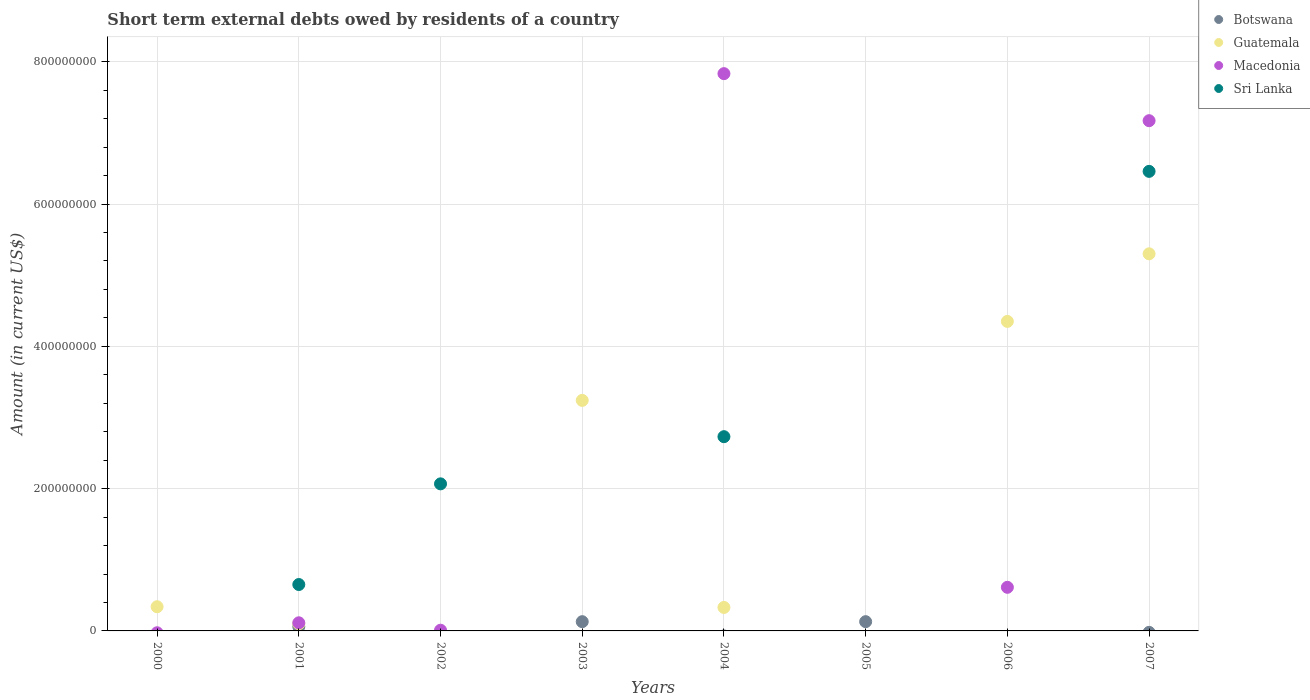How many different coloured dotlines are there?
Your answer should be compact. 4. What is the amount of short-term external debts owed by residents in Sri Lanka in 2000?
Provide a short and direct response. 0. Across all years, what is the maximum amount of short-term external debts owed by residents in Botswana?
Provide a short and direct response. 1.30e+07. What is the total amount of short-term external debts owed by residents in Macedonia in the graph?
Give a very brief answer. 1.57e+09. What is the difference between the amount of short-term external debts owed by residents in Sri Lanka in 2002 and that in 2004?
Keep it short and to the point. -6.63e+07. What is the difference between the amount of short-term external debts owed by residents in Sri Lanka in 2003 and the amount of short-term external debts owed by residents in Guatemala in 2005?
Your response must be concise. 0. In the year 2001, what is the difference between the amount of short-term external debts owed by residents in Botswana and amount of short-term external debts owed by residents in Sri Lanka?
Provide a short and direct response. -5.92e+07. In how many years, is the amount of short-term external debts owed by residents in Sri Lanka greater than 320000000 US$?
Your answer should be compact. 1. What is the ratio of the amount of short-term external debts owed by residents in Guatemala in 2000 to that in 2003?
Your response must be concise. 0.1. Is the amount of short-term external debts owed by residents in Macedonia in 2001 less than that in 2006?
Offer a terse response. Yes. What is the difference between the highest and the second highest amount of short-term external debts owed by residents in Macedonia?
Keep it short and to the point. 6.61e+07. What is the difference between the highest and the lowest amount of short-term external debts owed by residents in Botswana?
Your answer should be very brief. 1.30e+07. In how many years, is the amount of short-term external debts owed by residents in Sri Lanka greater than the average amount of short-term external debts owed by residents in Sri Lanka taken over all years?
Offer a very short reply. 3. How many years are there in the graph?
Provide a short and direct response. 8. What is the difference between two consecutive major ticks on the Y-axis?
Provide a short and direct response. 2.00e+08. Are the values on the major ticks of Y-axis written in scientific E-notation?
Ensure brevity in your answer.  No. Does the graph contain any zero values?
Your answer should be compact. Yes. Where does the legend appear in the graph?
Your answer should be very brief. Top right. How many legend labels are there?
Give a very brief answer. 4. What is the title of the graph?
Your response must be concise. Short term external debts owed by residents of a country. What is the label or title of the X-axis?
Give a very brief answer. Years. What is the Amount (in current US$) in Guatemala in 2000?
Provide a short and direct response. 3.40e+07. What is the Amount (in current US$) in Macedonia in 2000?
Make the answer very short. 0. What is the Amount (in current US$) in Macedonia in 2001?
Offer a very short reply. 1.14e+07. What is the Amount (in current US$) in Sri Lanka in 2001?
Your response must be concise. 6.52e+07. What is the Amount (in current US$) of Macedonia in 2002?
Make the answer very short. 9.95e+05. What is the Amount (in current US$) of Sri Lanka in 2002?
Make the answer very short. 2.07e+08. What is the Amount (in current US$) in Botswana in 2003?
Ensure brevity in your answer.  1.30e+07. What is the Amount (in current US$) in Guatemala in 2003?
Offer a very short reply. 3.24e+08. What is the Amount (in current US$) in Botswana in 2004?
Offer a terse response. 0. What is the Amount (in current US$) in Guatemala in 2004?
Your response must be concise. 3.30e+07. What is the Amount (in current US$) in Macedonia in 2004?
Ensure brevity in your answer.  7.83e+08. What is the Amount (in current US$) of Sri Lanka in 2004?
Offer a terse response. 2.73e+08. What is the Amount (in current US$) in Botswana in 2005?
Provide a short and direct response. 1.30e+07. What is the Amount (in current US$) of Macedonia in 2005?
Make the answer very short. 0. What is the Amount (in current US$) of Botswana in 2006?
Give a very brief answer. 0. What is the Amount (in current US$) in Guatemala in 2006?
Keep it short and to the point. 4.35e+08. What is the Amount (in current US$) in Macedonia in 2006?
Provide a short and direct response. 6.13e+07. What is the Amount (in current US$) of Sri Lanka in 2006?
Offer a very short reply. 0. What is the Amount (in current US$) in Botswana in 2007?
Give a very brief answer. 0. What is the Amount (in current US$) in Guatemala in 2007?
Provide a succinct answer. 5.30e+08. What is the Amount (in current US$) of Macedonia in 2007?
Your answer should be very brief. 7.17e+08. What is the Amount (in current US$) in Sri Lanka in 2007?
Give a very brief answer. 6.46e+08. Across all years, what is the maximum Amount (in current US$) in Botswana?
Your answer should be very brief. 1.30e+07. Across all years, what is the maximum Amount (in current US$) of Guatemala?
Your answer should be compact. 5.30e+08. Across all years, what is the maximum Amount (in current US$) of Macedonia?
Make the answer very short. 7.83e+08. Across all years, what is the maximum Amount (in current US$) in Sri Lanka?
Your answer should be compact. 6.46e+08. Across all years, what is the minimum Amount (in current US$) in Macedonia?
Make the answer very short. 0. What is the total Amount (in current US$) of Botswana in the graph?
Your answer should be compact. 3.20e+07. What is the total Amount (in current US$) of Guatemala in the graph?
Keep it short and to the point. 1.37e+09. What is the total Amount (in current US$) of Macedonia in the graph?
Ensure brevity in your answer.  1.57e+09. What is the total Amount (in current US$) of Sri Lanka in the graph?
Make the answer very short. 1.19e+09. What is the difference between the Amount (in current US$) of Guatemala in 2000 and that in 2001?
Your answer should be very brief. 2.40e+07. What is the difference between the Amount (in current US$) in Guatemala in 2000 and that in 2003?
Keep it short and to the point. -2.90e+08. What is the difference between the Amount (in current US$) in Guatemala in 2000 and that in 2006?
Keep it short and to the point. -4.01e+08. What is the difference between the Amount (in current US$) in Guatemala in 2000 and that in 2007?
Provide a short and direct response. -4.96e+08. What is the difference between the Amount (in current US$) in Macedonia in 2001 and that in 2002?
Provide a short and direct response. 1.04e+07. What is the difference between the Amount (in current US$) of Sri Lanka in 2001 and that in 2002?
Provide a short and direct response. -1.41e+08. What is the difference between the Amount (in current US$) of Botswana in 2001 and that in 2003?
Your answer should be compact. -7.00e+06. What is the difference between the Amount (in current US$) of Guatemala in 2001 and that in 2003?
Keep it short and to the point. -3.14e+08. What is the difference between the Amount (in current US$) of Guatemala in 2001 and that in 2004?
Provide a succinct answer. -2.30e+07. What is the difference between the Amount (in current US$) of Macedonia in 2001 and that in 2004?
Give a very brief answer. -7.72e+08. What is the difference between the Amount (in current US$) in Sri Lanka in 2001 and that in 2004?
Make the answer very short. -2.08e+08. What is the difference between the Amount (in current US$) in Botswana in 2001 and that in 2005?
Give a very brief answer. -7.00e+06. What is the difference between the Amount (in current US$) of Guatemala in 2001 and that in 2006?
Give a very brief answer. -4.25e+08. What is the difference between the Amount (in current US$) of Macedonia in 2001 and that in 2006?
Your answer should be compact. -4.99e+07. What is the difference between the Amount (in current US$) of Guatemala in 2001 and that in 2007?
Offer a terse response. -5.20e+08. What is the difference between the Amount (in current US$) of Macedonia in 2001 and that in 2007?
Give a very brief answer. -7.06e+08. What is the difference between the Amount (in current US$) of Sri Lanka in 2001 and that in 2007?
Your answer should be compact. -5.81e+08. What is the difference between the Amount (in current US$) in Macedonia in 2002 and that in 2004?
Offer a very short reply. -7.82e+08. What is the difference between the Amount (in current US$) of Sri Lanka in 2002 and that in 2004?
Provide a succinct answer. -6.63e+07. What is the difference between the Amount (in current US$) in Macedonia in 2002 and that in 2006?
Ensure brevity in your answer.  -6.03e+07. What is the difference between the Amount (in current US$) in Macedonia in 2002 and that in 2007?
Make the answer very short. -7.16e+08. What is the difference between the Amount (in current US$) of Sri Lanka in 2002 and that in 2007?
Your response must be concise. -4.39e+08. What is the difference between the Amount (in current US$) of Guatemala in 2003 and that in 2004?
Your answer should be compact. 2.91e+08. What is the difference between the Amount (in current US$) in Botswana in 2003 and that in 2005?
Offer a terse response. 0. What is the difference between the Amount (in current US$) of Guatemala in 2003 and that in 2006?
Give a very brief answer. -1.11e+08. What is the difference between the Amount (in current US$) of Guatemala in 2003 and that in 2007?
Your answer should be very brief. -2.06e+08. What is the difference between the Amount (in current US$) in Guatemala in 2004 and that in 2006?
Your answer should be very brief. -4.02e+08. What is the difference between the Amount (in current US$) of Macedonia in 2004 and that in 2006?
Offer a terse response. 7.22e+08. What is the difference between the Amount (in current US$) in Guatemala in 2004 and that in 2007?
Ensure brevity in your answer.  -4.97e+08. What is the difference between the Amount (in current US$) of Macedonia in 2004 and that in 2007?
Your response must be concise. 6.61e+07. What is the difference between the Amount (in current US$) in Sri Lanka in 2004 and that in 2007?
Your answer should be very brief. -3.73e+08. What is the difference between the Amount (in current US$) in Guatemala in 2006 and that in 2007?
Make the answer very short. -9.50e+07. What is the difference between the Amount (in current US$) of Macedonia in 2006 and that in 2007?
Your response must be concise. -6.56e+08. What is the difference between the Amount (in current US$) in Guatemala in 2000 and the Amount (in current US$) in Macedonia in 2001?
Offer a very short reply. 2.26e+07. What is the difference between the Amount (in current US$) in Guatemala in 2000 and the Amount (in current US$) in Sri Lanka in 2001?
Make the answer very short. -3.12e+07. What is the difference between the Amount (in current US$) in Guatemala in 2000 and the Amount (in current US$) in Macedonia in 2002?
Offer a very short reply. 3.30e+07. What is the difference between the Amount (in current US$) in Guatemala in 2000 and the Amount (in current US$) in Sri Lanka in 2002?
Ensure brevity in your answer.  -1.73e+08. What is the difference between the Amount (in current US$) of Guatemala in 2000 and the Amount (in current US$) of Macedonia in 2004?
Provide a succinct answer. -7.49e+08. What is the difference between the Amount (in current US$) in Guatemala in 2000 and the Amount (in current US$) in Sri Lanka in 2004?
Provide a succinct answer. -2.39e+08. What is the difference between the Amount (in current US$) of Guatemala in 2000 and the Amount (in current US$) of Macedonia in 2006?
Ensure brevity in your answer.  -2.73e+07. What is the difference between the Amount (in current US$) of Guatemala in 2000 and the Amount (in current US$) of Macedonia in 2007?
Your answer should be compact. -6.83e+08. What is the difference between the Amount (in current US$) of Guatemala in 2000 and the Amount (in current US$) of Sri Lanka in 2007?
Your response must be concise. -6.12e+08. What is the difference between the Amount (in current US$) in Botswana in 2001 and the Amount (in current US$) in Macedonia in 2002?
Give a very brief answer. 5.00e+06. What is the difference between the Amount (in current US$) of Botswana in 2001 and the Amount (in current US$) of Sri Lanka in 2002?
Make the answer very short. -2.01e+08. What is the difference between the Amount (in current US$) in Guatemala in 2001 and the Amount (in current US$) in Macedonia in 2002?
Your answer should be compact. 9.00e+06. What is the difference between the Amount (in current US$) in Guatemala in 2001 and the Amount (in current US$) in Sri Lanka in 2002?
Ensure brevity in your answer.  -1.97e+08. What is the difference between the Amount (in current US$) in Macedonia in 2001 and the Amount (in current US$) in Sri Lanka in 2002?
Offer a very short reply. -1.95e+08. What is the difference between the Amount (in current US$) of Botswana in 2001 and the Amount (in current US$) of Guatemala in 2003?
Ensure brevity in your answer.  -3.18e+08. What is the difference between the Amount (in current US$) in Botswana in 2001 and the Amount (in current US$) in Guatemala in 2004?
Offer a very short reply. -2.70e+07. What is the difference between the Amount (in current US$) of Botswana in 2001 and the Amount (in current US$) of Macedonia in 2004?
Keep it short and to the point. -7.77e+08. What is the difference between the Amount (in current US$) of Botswana in 2001 and the Amount (in current US$) of Sri Lanka in 2004?
Ensure brevity in your answer.  -2.67e+08. What is the difference between the Amount (in current US$) of Guatemala in 2001 and the Amount (in current US$) of Macedonia in 2004?
Provide a short and direct response. -7.73e+08. What is the difference between the Amount (in current US$) in Guatemala in 2001 and the Amount (in current US$) in Sri Lanka in 2004?
Keep it short and to the point. -2.63e+08. What is the difference between the Amount (in current US$) in Macedonia in 2001 and the Amount (in current US$) in Sri Lanka in 2004?
Provide a short and direct response. -2.62e+08. What is the difference between the Amount (in current US$) in Botswana in 2001 and the Amount (in current US$) in Guatemala in 2006?
Make the answer very short. -4.29e+08. What is the difference between the Amount (in current US$) in Botswana in 2001 and the Amount (in current US$) in Macedonia in 2006?
Give a very brief answer. -5.53e+07. What is the difference between the Amount (in current US$) of Guatemala in 2001 and the Amount (in current US$) of Macedonia in 2006?
Your answer should be very brief. -5.13e+07. What is the difference between the Amount (in current US$) of Botswana in 2001 and the Amount (in current US$) of Guatemala in 2007?
Your response must be concise. -5.24e+08. What is the difference between the Amount (in current US$) of Botswana in 2001 and the Amount (in current US$) of Macedonia in 2007?
Your answer should be very brief. -7.11e+08. What is the difference between the Amount (in current US$) of Botswana in 2001 and the Amount (in current US$) of Sri Lanka in 2007?
Provide a short and direct response. -6.40e+08. What is the difference between the Amount (in current US$) in Guatemala in 2001 and the Amount (in current US$) in Macedonia in 2007?
Your answer should be very brief. -7.07e+08. What is the difference between the Amount (in current US$) of Guatemala in 2001 and the Amount (in current US$) of Sri Lanka in 2007?
Ensure brevity in your answer.  -6.36e+08. What is the difference between the Amount (in current US$) in Macedonia in 2001 and the Amount (in current US$) in Sri Lanka in 2007?
Make the answer very short. -6.34e+08. What is the difference between the Amount (in current US$) in Macedonia in 2002 and the Amount (in current US$) in Sri Lanka in 2004?
Provide a short and direct response. -2.72e+08. What is the difference between the Amount (in current US$) of Macedonia in 2002 and the Amount (in current US$) of Sri Lanka in 2007?
Ensure brevity in your answer.  -6.45e+08. What is the difference between the Amount (in current US$) of Botswana in 2003 and the Amount (in current US$) of Guatemala in 2004?
Your answer should be compact. -2.00e+07. What is the difference between the Amount (in current US$) of Botswana in 2003 and the Amount (in current US$) of Macedonia in 2004?
Your answer should be very brief. -7.70e+08. What is the difference between the Amount (in current US$) of Botswana in 2003 and the Amount (in current US$) of Sri Lanka in 2004?
Offer a very short reply. -2.60e+08. What is the difference between the Amount (in current US$) of Guatemala in 2003 and the Amount (in current US$) of Macedonia in 2004?
Keep it short and to the point. -4.59e+08. What is the difference between the Amount (in current US$) of Guatemala in 2003 and the Amount (in current US$) of Sri Lanka in 2004?
Give a very brief answer. 5.10e+07. What is the difference between the Amount (in current US$) of Botswana in 2003 and the Amount (in current US$) of Guatemala in 2006?
Provide a short and direct response. -4.22e+08. What is the difference between the Amount (in current US$) of Botswana in 2003 and the Amount (in current US$) of Macedonia in 2006?
Keep it short and to the point. -4.83e+07. What is the difference between the Amount (in current US$) of Guatemala in 2003 and the Amount (in current US$) of Macedonia in 2006?
Provide a succinct answer. 2.63e+08. What is the difference between the Amount (in current US$) of Botswana in 2003 and the Amount (in current US$) of Guatemala in 2007?
Offer a very short reply. -5.17e+08. What is the difference between the Amount (in current US$) in Botswana in 2003 and the Amount (in current US$) in Macedonia in 2007?
Your answer should be very brief. -7.04e+08. What is the difference between the Amount (in current US$) in Botswana in 2003 and the Amount (in current US$) in Sri Lanka in 2007?
Provide a succinct answer. -6.33e+08. What is the difference between the Amount (in current US$) of Guatemala in 2003 and the Amount (in current US$) of Macedonia in 2007?
Ensure brevity in your answer.  -3.93e+08. What is the difference between the Amount (in current US$) in Guatemala in 2003 and the Amount (in current US$) in Sri Lanka in 2007?
Ensure brevity in your answer.  -3.22e+08. What is the difference between the Amount (in current US$) in Guatemala in 2004 and the Amount (in current US$) in Macedonia in 2006?
Offer a terse response. -2.83e+07. What is the difference between the Amount (in current US$) of Guatemala in 2004 and the Amount (in current US$) of Macedonia in 2007?
Make the answer very short. -6.84e+08. What is the difference between the Amount (in current US$) of Guatemala in 2004 and the Amount (in current US$) of Sri Lanka in 2007?
Make the answer very short. -6.13e+08. What is the difference between the Amount (in current US$) in Macedonia in 2004 and the Amount (in current US$) in Sri Lanka in 2007?
Offer a terse response. 1.37e+08. What is the difference between the Amount (in current US$) in Botswana in 2005 and the Amount (in current US$) in Guatemala in 2006?
Your answer should be very brief. -4.22e+08. What is the difference between the Amount (in current US$) of Botswana in 2005 and the Amount (in current US$) of Macedonia in 2006?
Your answer should be compact. -4.83e+07. What is the difference between the Amount (in current US$) of Botswana in 2005 and the Amount (in current US$) of Guatemala in 2007?
Ensure brevity in your answer.  -5.17e+08. What is the difference between the Amount (in current US$) of Botswana in 2005 and the Amount (in current US$) of Macedonia in 2007?
Ensure brevity in your answer.  -7.04e+08. What is the difference between the Amount (in current US$) in Botswana in 2005 and the Amount (in current US$) in Sri Lanka in 2007?
Ensure brevity in your answer.  -6.33e+08. What is the difference between the Amount (in current US$) of Guatemala in 2006 and the Amount (in current US$) of Macedonia in 2007?
Make the answer very short. -2.82e+08. What is the difference between the Amount (in current US$) in Guatemala in 2006 and the Amount (in current US$) in Sri Lanka in 2007?
Offer a very short reply. -2.11e+08. What is the difference between the Amount (in current US$) in Macedonia in 2006 and the Amount (in current US$) in Sri Lanka in 2007?
Provide a short and direct response. -5.85e+08. What is the average Amount (in current US$) of Botswana per year?
Offer a terse response. 4.00e+06. What is the average Amount (in current US$) in Guatemala per year?
Give a very brief answer. 1.71e+08. What is the average Amount (in current US$) of Macedonia per year?
Keep it short and to the point. 1.97e+08. What is the average Amount (in current US$) of Sri Lanka per year?
Provide a succinct answer. 1.49e+08. In the year 2001, what is the difference between the Amount (in current US$) of Botswana and Amount (in current US$) of Guatemala?
Give a very brief answer. -4.00e+06. In the year 2001, what is the difference between the Amount (in current US$) in Botswana and Amount (in current US$) in Macedonia?
Provide a succinct answer. -5.42e+06. In the year 2001, what is the difference between the Amount (in current US$) in Botswana and Amount (in current US$) in Sri Lanka?
Your answer should be very brief. -5.92e+07. In the year 2001, what is the difference between the Amount (in current US$) in Guatemala and Amount (in current US$) in Macedonia?
Your response must be concise. -1.42e+06. In the year 2001, what is the difference between the Amount (in current US$) of Guatemala and Amount (in current US$) of Sri Lanka?
Offer a terse response. -5.52e+07. In the year 2001, what is the difference between the Amount (in current US$) of Macedonia and Amount (in current US$) of Sri Lanka?
Offer a very short reply. -5.38e+07. In the year 2002, what is the difference between the Amount (in current US$) in Macedonia and Amount (in current US$) in Sri Lanka?
Ensure brevity in your answer.  -2.06e+08. In the year 2003, what is the difference between the Amount (in current US$) in Botswana and Amount (in current US$) in Guatemala?
Provide a short and direct response. -3.11e+08. In the year 2004, what is the difference between the Amount (in current US$) of Guatemala and Amount (in current US$) of Macedonia?
Give a very brief answer. -7.50e+08. In the year 2004, what is the difference between the Amount (in current US$) in Guatemala and Amount (in current US$) in Sri Lanka?
Your answer should be compact. -2.40e+08. In the year 2004, what is the difference between the Amount (in current US$) in Macedonia and Amount (in current US$) in Sri Lanka?
Ensure brevity in your answer.  5.10e+08. In the year 2006, what is the difference between the Amount (in current US$) in Guatemala and Amount (in current US$) in Macedonia?
Keep it short and to the point. 3.74e+08. In the year 2007, what is the difference between the Amount (in current US$) of Guatemala and Amount (in current US$) of Macedonia?
Provide a short and direct response. -1.87e+08. In the year 2007, what is the difference between the Amount (in current US$) of Guatemala and Amount (in current US$) of Sri Lanka?
Ensure brevity in your answer.  -1.16e+08. In the year 2007, what is the difference between the Amount (in current US$) in Macedonia and Amount (in current US$) in Sri Lanka?
Provide a succinct answer. 7.12e+07. What is the ratio of the Amount (in current US$) in Guatemala in 2000 to that in 2003?
Make the answer very short. 0.1. What is the ratio of the Amount (in current US$) of Guatemala in 2000 to that in 2004?
Your answer should be compact. 1.03. What is the ratio of the Amount (in current US$) in Guatemala in 2000 to that in 2006?
Provide a succinct answer. 0.08. What is the ratio of the Amount (in current US$) in Guatemala in 2000 to that in 2007?
Offer a terse response. 0.06. What is the ratio of the Amount (in current US$) in Macedonia in 2001 to that in 2002?
Ensure brevity in your answer.  11.48. What is the ratio of the Amount (in current US$) in Sri Lanka in 2001 to that in 2002?
Offer a terse response. 0.32. What is the ratio of the Amount (in current US$) of Botswana in 2001 to that in 2003?
Offer a very short reply. 0.46. What is the ratio of the Amount (in current US$) in Guatemala in 2001 to that in 2003?
Offer a terse response. 0.03. What is the ratio of the Amount (in current US$) in Guatemala in 2001 to that in 2004?
Ensure brevity in your answer.  0.3. What is the ratio of the Amount (in current US$) of Macedonia in 2001 to that in 2004?
Provide a succinct answer. 0.01. What is the ratio of the Amount (in current US$) of Sri Lanka in 2001 to that in 2004?
Your response must be concise. 0.24. What is the ratio of the Amount (in current US$) in Botswana in 2001 to that in 2005?
Offer a very short reply. 0.46. What is the ratio of the Amount (in current US$) of Guatemala in 2001 to that in 2006?
Ensure brevity in your answer.  0.02. What is the ratio of the Amount (in current US$) of Macedonia in 2001 to that in 2006?
Ensure brevity in your answer.  0.19. What is the ratio of the Amount (in current US$) in Guatemala in 2001 to that in 2007?
Offer a terse response. 0.02. What is the ratio of the Amount (in current US$) in Macedonia in 2001 to that in 2007?
Provide a short and direct response. 0.02. What is the ratio of the Amount (in current US$) of Sri Lanka in 2001 to that in 2007?
Your answer should be compact. 0.1. What is the ratio of the Amount (in current US$) of Macedonia in 2002 to that in 2004?
Your response must be concise. 0. What is the ratio of the Amount (in current US$) in Sri Lanka in 2002 to that in 2004?
Provide a succinct answer. 0.76. What is the ratio of the Amount (in current US$) of Macedonia in 2002 to that in 2006?
Keep it short and to the point. 0.02. What is the ratio of the Amount (in current US$) in Macedonia in 2002 to that in 2007?
Offer a terse response. 0. What is the ratio of the Amount (in current US$) in Sri Lanka in 2002 to that in 2007?
Keep it short and to the point. 0.32. What is the ratio of the Amount (in current US$) of Guatemala in 2003 to that in 2004?
Your response must be concise. 9.82. What is the ratio of the Amount (in current US$) in Guatemala in 2003 to that in 2006?
Ensure brevity in your answer.  0.74. What is the ratio of the Amount (in current US$) of Guatemala in 2003 to that in 2007?
Your answer should be very brief. 0.61. What is the ratio of the Amount (in current US$) of Guatemala in 2004 to that in 2006?
Ensure brevity in your answer.  0.08. What is the ratio of the Amount (in current US$) in Macedonia in 2004 to that in 2006?
Your response must be concise. 12.78. What is the ratio of the Amount (in current US$) in Guatemala in 2004 to that in 2007?
Your answer should be very brief. 0.06. What is the ratio of the Amount (in current US$) of Macedonia in 2004 to that in 2007?
Your answer should be very brief. 1.09. What is the ratio of the Amount (in current US$) in Sri Lanka in 2004 to that in 2007?
Your answer should be very brief. 0.42. What is the ratio of the Amount (in current US$) in Guatemala in 2006 to that in 2007?
Your response must be concise. 0.82. What is the ratio of the Amount (in current US$) in Macedonia in 2006 to that in 2007?
Your answer should be very brief. 0.09. What is the difference between the highest and the second highest Amount (in current US$) of Botswana?
Offer a terse response. 0. What is the difference between the highest and the second highest Amount (in current US$) of Guatemala?
Provide a short and direct response. 9.50e+07. What is the difference between the highest and the second highest Amount (in current US$) of Macedonia?
Your response must be concise. 6.61e+07. What is the difference between the highest and the second highest Amount (in current US$) of Sri Lanka?
Make the answer very short. 3.73e+08. What is the difference between the highest and the lowest Amount (in current US$) of Botswana?
Your response must be concise. 1.30e+07. What is the difference between the highest and the lowest Amount (in current US$) of Guatemala?
Your answer should be compact. 5.30e+08. What is the difference between the highest and the lowest Amount (in current US$) in Macedonia?
Make the answer very short. 7.83e+08. What is the difference between the highest and the lowest Amount (in current US$) of Sri Lanka?
Provide a short and direct response. 6.46e+08. 